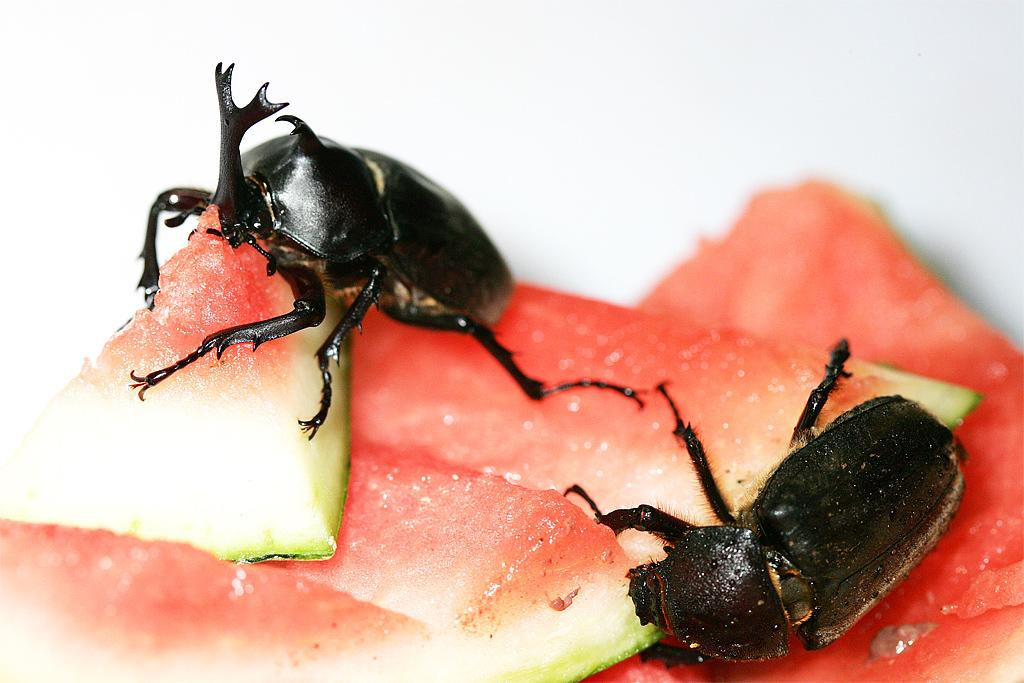What type of insects are in the image? There are two rhinoceros beetles in the image. What are the rhinoceros beetles doing in the image? The rhinoceros beetles are on a watermelon. What type of scarf is the rhinoceros beetle wearing in the image? There is no scarf present in the image; the rhinoceros beetles are on a watermelon. 